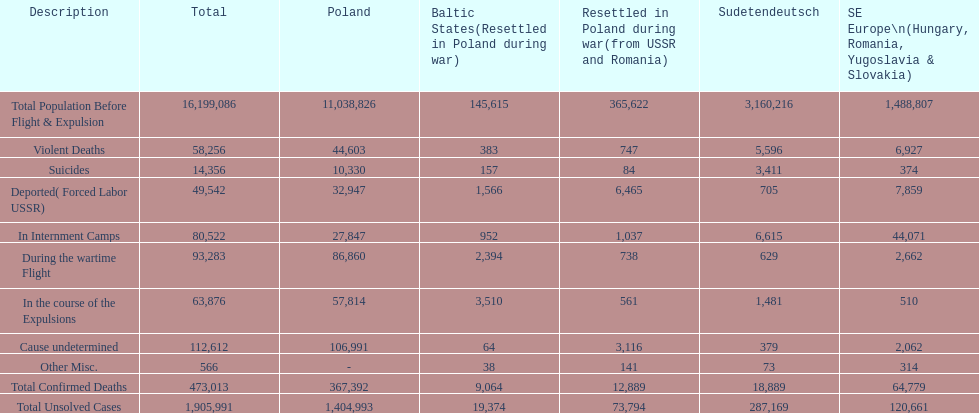Parse the table in full. {'header': ['Description', 'Total', 'Poland', 'Baltic States(Resettled in Poland during war)', 'Resettled in Poland during war(from USSR and Romania)', 'Sudetendeutsch', 'SE Europe\\n(Hungary, Romania, Yugoslavia & Slovakia)'], 'rows': [['Total Population Before Flight & Expulsion', '16,199,086', '11,038,826', '145,615', '365,622', '3,160,216', '1,488,807'], ['Violent Deaths', '58,256', '44,603', '383', '747', '5,596', '6,927'], ['Suicides', '14,356', '10,330', '157', '84', '3,411', '374'], ['Deported( Forced Labor USSR)', '49,542', '32,947', '1,566', '6,465', '705', '7,859'], ['In Internment Camps', '80,522', '27,847', '952', '1,037', '6,615', '44,071'], ['During the wartime Flight', '93,283', '86,860', '2,394', '738', '629', '2,662'], ['In the course of the Expulsions', '63,876', '57,814', '3,510', '561', '1,481', '510'], ['Cause undetermined', '112,612', '106,991', '64', '3,116', '379', '2,062'], ['Other Misc.', '566', '-', '38', '141', '73', '314'], ['Total Confirmed Deaths', '473,013', '367,392', '9,064', '12,889', '18,889', '64,779'], ['Total Unsolved Cases', '1,905,991', '1,404,993', '19,374', '73,794', '287,169', '120,661']]} Did poland or sudetendeutsch have a higher total population prior to expulsion? Poland. 